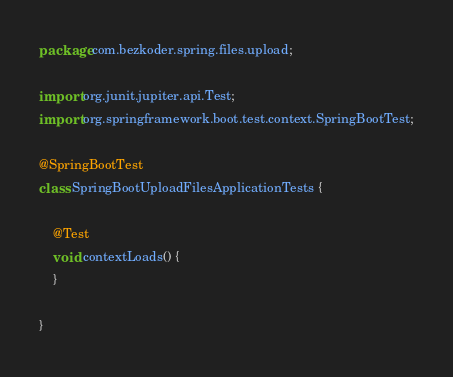Convert code to text. <code><loc_0><loc_0><loc_500><loc_500><_Java_>package com.bezkoder.spring.files.upload;

import org.junit.jupiter.api.Test;
import org.springframework.boot.test.context.SpringBootTest;

@SpringBootTest
class SpringBootUploadFilesApplicationTests {

	@Test
	void contextLoads() {
	}

}
</code> 